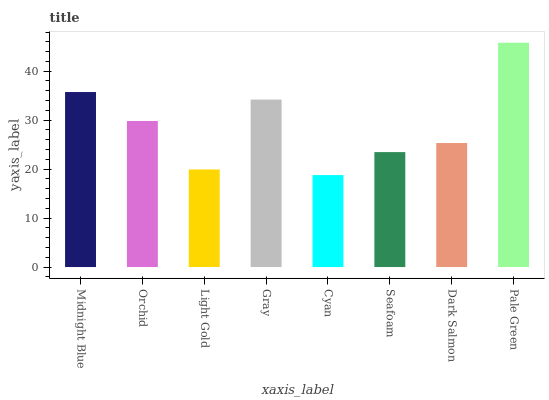Is Cyan the minimum?
Answer yes or no. Yes. Is Pale Green the maximum?
Answer yes or no. Yes. Is Orchid the minimum?
Answer yes or no. No. Is Orchid the maximum?
Answer yes or no. No. Is Midnight Blue greater than Orchid?
Answer yes or no. Yes. Is Orchid less than Midnight Blue?
Answer yes or no. Yes. Is Orchid greater than Midnight Blue?
Answer yes or no. No. Is Midnight Blue less than Orchid?
Answer yes or no. No. Is Orchid the high median?
Answer yes or no. Yes. Is Dark Salmon the low median?
Answer yes or no. Yes. Is Midnight Blue the high median?
Answer yes or no. No. Is Cyan the low median?
Answer yes or no. No. 